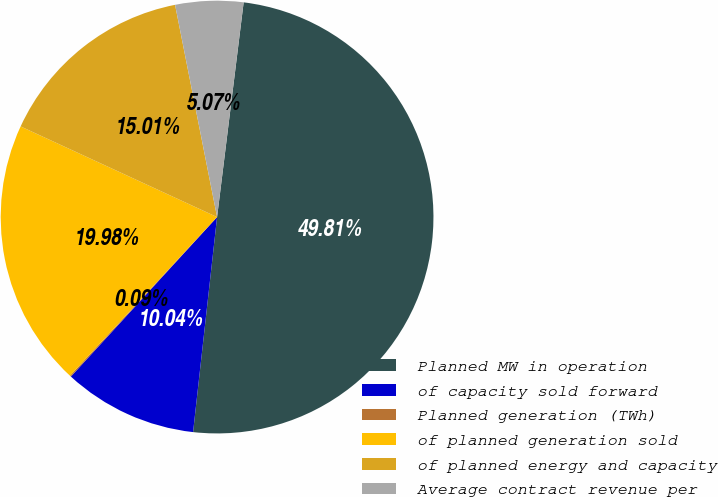Convert chart to OTSL. <chart><loc_0><loc_0><loc_500><loc_500><pie_chart><fcel>Planned MW in operation<fcel>of capacity sold forward<fcel>Planned generation (TWh)<fcel>of planned generation sold<fcel>of planned energy and capacity<fcel>Average contract revenue per<nl><fcel>49.81%<fcel>10.04%<fcel>0.09%<fcel>19.98%<fcel>15.01%<fcel>5.07%<nl></chart> 